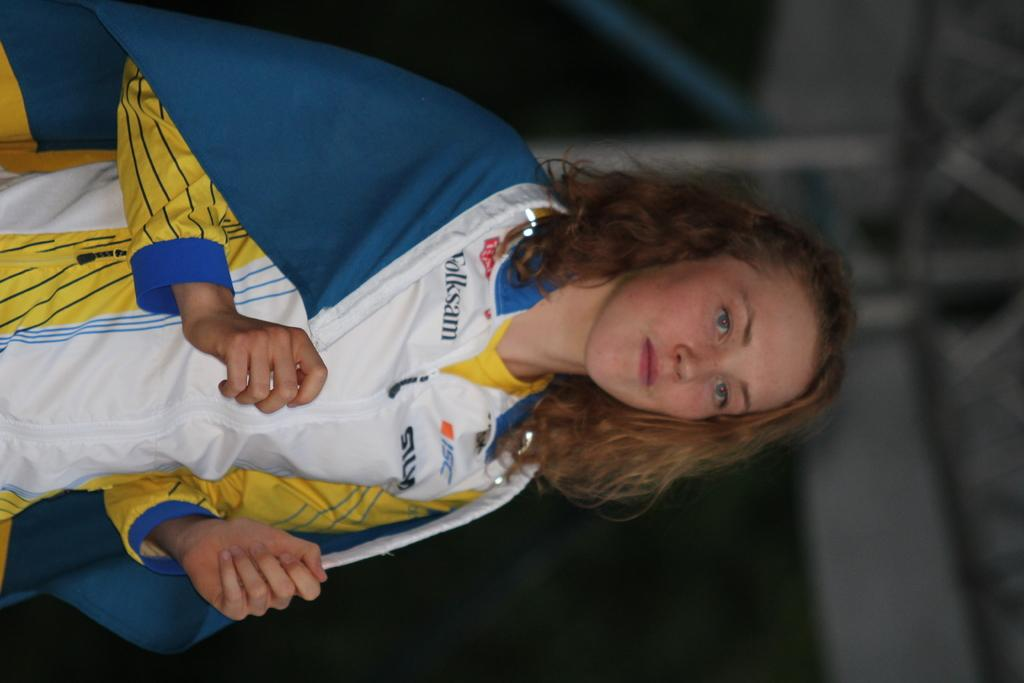Provide a one-sentence caption for the provided image. A gilr wearing a white top with Folksam and ISC written on it drapes a blue flag over her shoulders. 